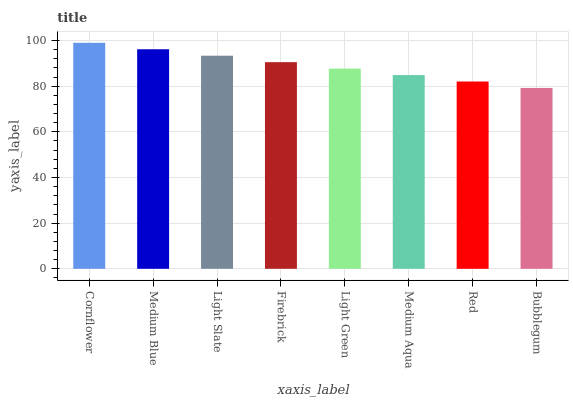Is Bubblegum the minimum?
Answer yes or no. Yes. Is Cornflower the maximum?
Answer yes or no. Yes. Is Medium Blue the minimum?
Answer yes or no. No. Is Medium Blue the maximum?
Answer yes or no. No. Is Cornflower greater than Medium Blue?
Answer yes or no. Yes. Is Medium Blue less than Cornflower?
Answer yes or no. Yes. Is Medium Blue greater than Cornflower?
Answer yes or no. No. Is Cornflower less than Medium Blue?
Answer yes or no. No. Is Firebrick the high median?
Answer yes or no. Yes. Is Light Green the low median?
Answer yes or no. Yes. Is Cornflower the high median?
Answer yes or no. No. Is Medium Aqua the low median?
Answer yes or no. No. 